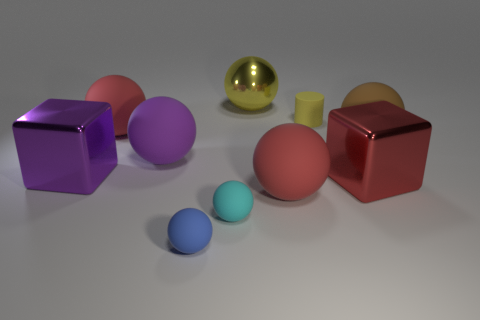Subtract all large yellow spheres. How many spheres are left? 6 Subtract 1 spheres. How many spheres are left? 6 Subtract all cyan spheres. How many spheres are left? 6 Subtract all cylinders. How many objects are left? 9 Subtract all blue balls. Subtract all brown blocks. How many balls are left? 6 Add 4 big spheres. How many big spheres are left? 9 Add 4 large brown rubber objects. How many large brown rubber objects exist? 5 Subtract 1 red spheres. How many objects are left? 9 Subtract all big purple rubber spheres. Subtract all large shiny cylinders. How many objects are left? 9 